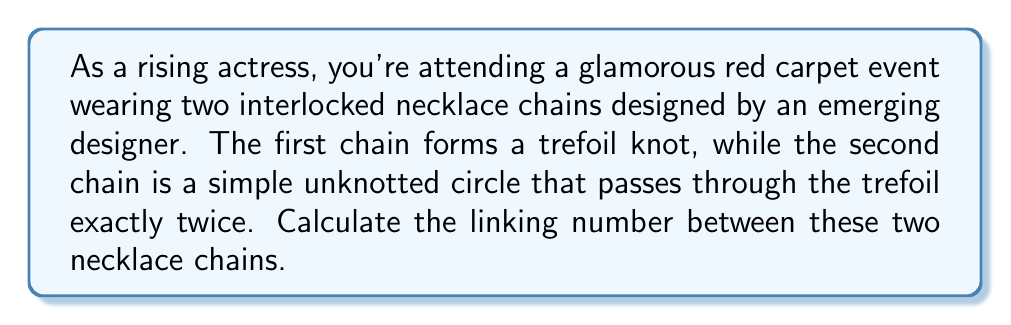Provide a solution to this math problem. To calculate the linking number between the two necklace chains, we'll follow these steps:

1. Understand the concept:
   The linking number is a topological invariant that measures how two closed curves are linked in three-dimensional space. It's calculated as half the sum of the signed crossings between the two curves.

2. Identify the crossings:
   In this case, we have a trefoil knot (first chain) linked with a simple circle (second chain). The circle passes through the trefoil twice, creating two crossings.

3. Determine the sign of each crossing:
   For each crossing, we need to determine if it's positive or negative. This is done by applying the right-hand rule:
   - Point your right thumb in the direction of the overcrossing strand.
   - If your fingers curl in the direction of the undercrossing strand, it's a positive crossing (+1).
   - If they curl in the opposite direction, it's a negative crossing (-1).

   [asy]
   import geometry;

   size(200);
   
   path trefoil = (0,0)..(-1,1)..(0,2)..(1,1)..(0,0)..(1,-1)..(2,0)..(1,1);
   path circle = circle((0.5,0.5),0.7);

   draw(trefoil, blue);
   draw(circle, red);
   
   dot((0.2,0.5), black);
   dot((0.8,0.5), black);
   
   label("$+$", (0.2,0.7), black);
   label("$+$", (0.8,0.7), black);
   [/asy]

4. Sum the signed crossings:
   In this case, both crossings are positive, so we have:
   $$(+1) + (+1) = 2$$

5. Calculate the linking number:
   The linking number is half the sum of the signed crossings:
   $$\text{Linking Number} = \frac{1}{2} \sum \text{(signed crossings)} = \frac{1}{2} \cdot 2 = 1$$

Therefore, the linking number between the two necklace chains is 1.
Answer: 1 